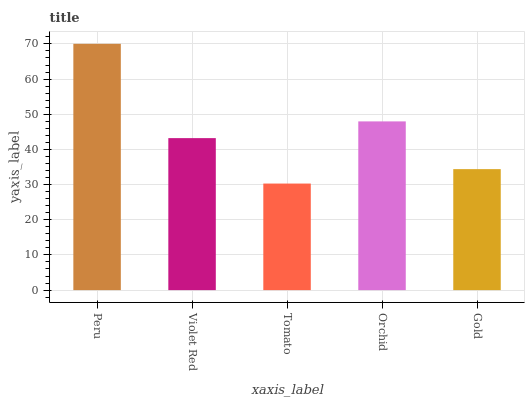Is Tomato the minimum?
Answer yes or no. Yes. Is Peru the maximum?
Answer yes or no. Yes. Is Violet Red the minimum?
Answer yes or no. No. Is Violet Red the maximum?
Answer yes or no. No. Is Peru greater than Violet Red?
Answer yes or no. Yes. Is Violet Red less than Peru?
Answer yes or no. Yes. Is Violet Red greater than Peru?
Answer yes or no. No. Is Peru less than Violet Red?
Answer yes or no. No. Is Violet Red the high median?
Answer yes or no. Yes. Is Violet Red the low median?
Answer yes or no. Yes. Is Gold the high median?
Answer yes or no. No. Is Tomato the low median?
Answer yes or no. No. 